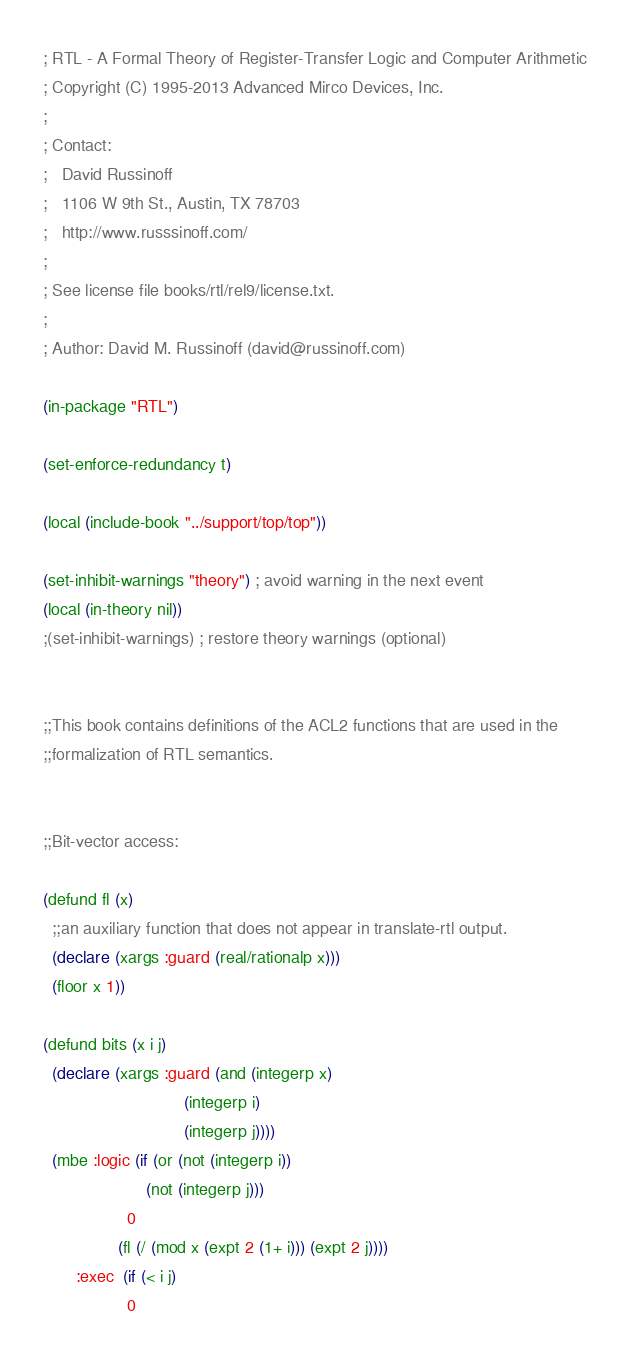<code> <loc_0><loc_0><loc_500><loc_500><_Lisp_>; RTL - A Formal Theory of Register-Transfer Logic and Computer Arithmetic
; Copyright (C) 1995-2013 Advanced Mirco Devices, Inc.
;
; Contact:
;   David Russinoff
;   1106 W 9th St., Austin, TX 78703
;   http://www.russsinoff.com/
;
; See license file books/rtl/rel9/license.txt.
;
; Author: David M. Russinoff (david@russinoff.com)

(in-package "RTL")

(set-enforce-redundancy t)

(local (include-book "../support/top/top"))

(set-inhibit-warnings "theory") ; avoid warning in the next event
(local (in-theory nil))
;(set-inhibit-warnings) ; restore theory warnings (optional)


;;This book contains definitions of the ACL2 functions that are used in the
;;formalization of RTL semantics.


;;Bit-vector access:

(defund fl (x)
  ;;an auxiliary function that does not appear in translate-rtl output.
  (declare (xargs :guard (real/rationalp x)))
  (floor x 1))

(defund bits (x i j)
  (declare (xargs :guard (and (integerp x)
                              (integerp i)
                              (integerp j))))
  (mbe :logic (if (or (not (integerp i))
                      (not (integerp j)))
                  0
                (fl (/ (mod x (expt 2 (1+ i))) (expt 2 j))))
       :exec  (if (< i j)
                  0</code> 